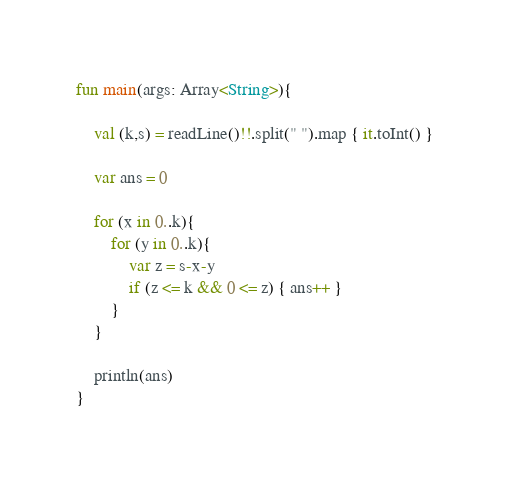Convert code to text. <code><loc_0><loc_0><loc_500><loc_500><_Kotlin_>
fun main(args: Array<String>){
    
    val (k,s) = readLine()!!.split(" ").map { it.toInt() }
    
    var ans = 0

    for (x in 0..k){
        for (y in 0..k){
            var z = s-x-y
            if (z <= k && 0 <= z) { ans++ }
        }
    }

    println(ans)
}</code> 